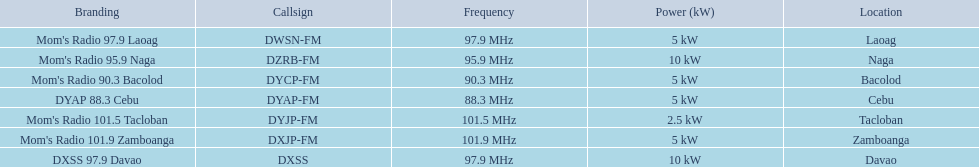How many stations have at least 5 kw or more listed in the power column? 6. Parse the table in full. {'header': ['Branding', 'Callsign', 'Frequency', 'Power (kW)', 'Location'], 'rows': [["Mom's Radio 97.9 Laoag", 'DWSN-FM', '97.9\xa0MHz', '5\xa0kW', 'Laoag'], ["Mom's Radio 95.9 Naga", 'DZRB-FM', '95.9\xa0MHz', '10\xa0kW', 'Naga'], ["Mom's Radio 90.3 Bacolod", 'DYCP-FM', '90.3\xa0MHz', '5\xa0kW', 'Bacolod'], ['DYAP 88.3 Cebu', 'DYAP-FM', '88.3\xa0MHz', '5\xa0kW', 'Cebu'], ["Mom's Radio 101.5 Tacloban", 'DYJP-FM', '101.5\xa0MHz', '2.5\xa0kW', 'Tacloban'], ["Mom's Radio 101.9 Zamboanga", 'DXJP-FM', '101.9\xa0MHz', '5\xa0kW', 'Zamboanga'], ['DXSS 97.9 Davao', 'DXSS', '97.9\xa0MHz', '10\xa0kW', 'Davao']]} 